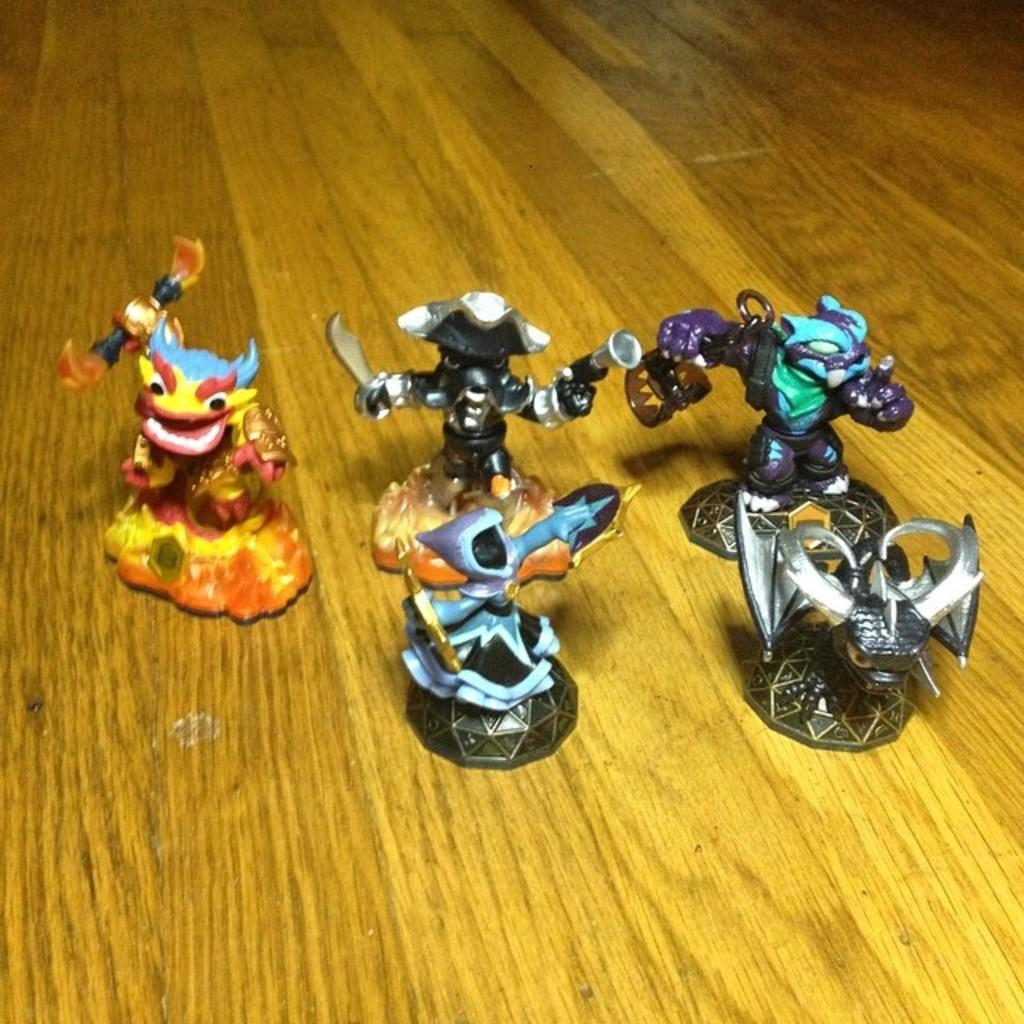How many toys are visible in the image? There are five toys in the image. Where are the toys located? The toys are on a table. What type of stone can be seen supporting the scarecrow in the image? There is no stone or scarecrow present in the image; it only features five toys on a table. 